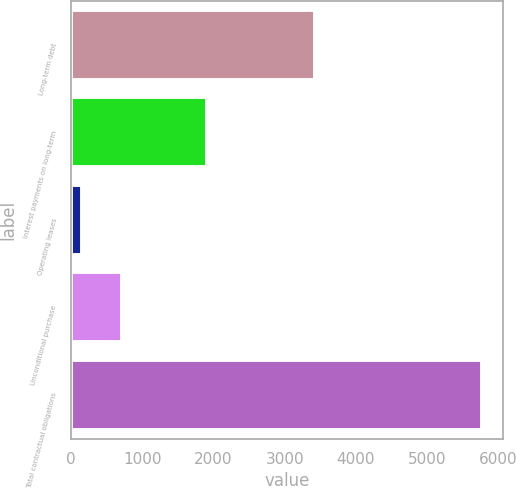<chart> <loc_0><loc_0><loc_500><loc_500><bar_chart><fcel>Long-term debt<fcel>Interest payments on long-term<fcel>Operating leases<fcel>Unconditional purchase<fcel>Total contractual obligations<nl><fcel>3422<fcel>1909<fcel>153<fcel>714.9<fcel>5772<nl></chart> 